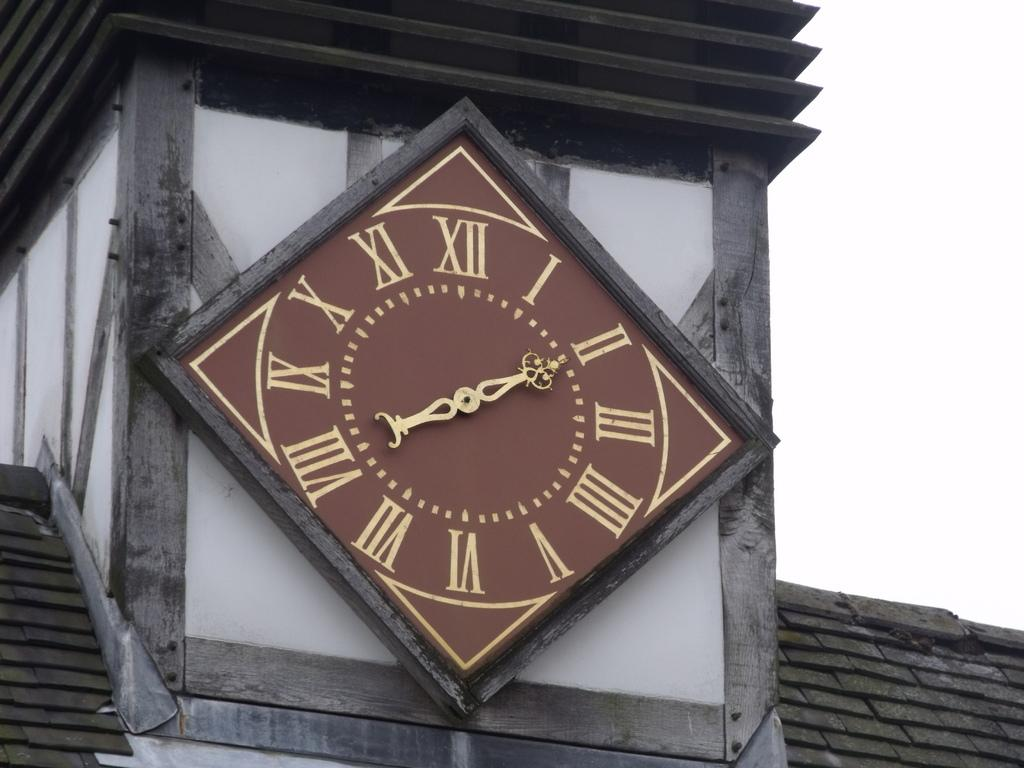What is located in the middle of the image? There is a clock on a platform in the middle of the image. What can be seen on the left side of the image? There is a roof on the left side of the image. What can be seen on the right side of the image? There is a roof on the right side of the image, and the sky is also visible on the right side of the image. What type of pail is being used by the representative in the image? There is no pail or representative present in the image. What kind of drum can be heard in the background of the image? There is no drum or sound present in the image. 